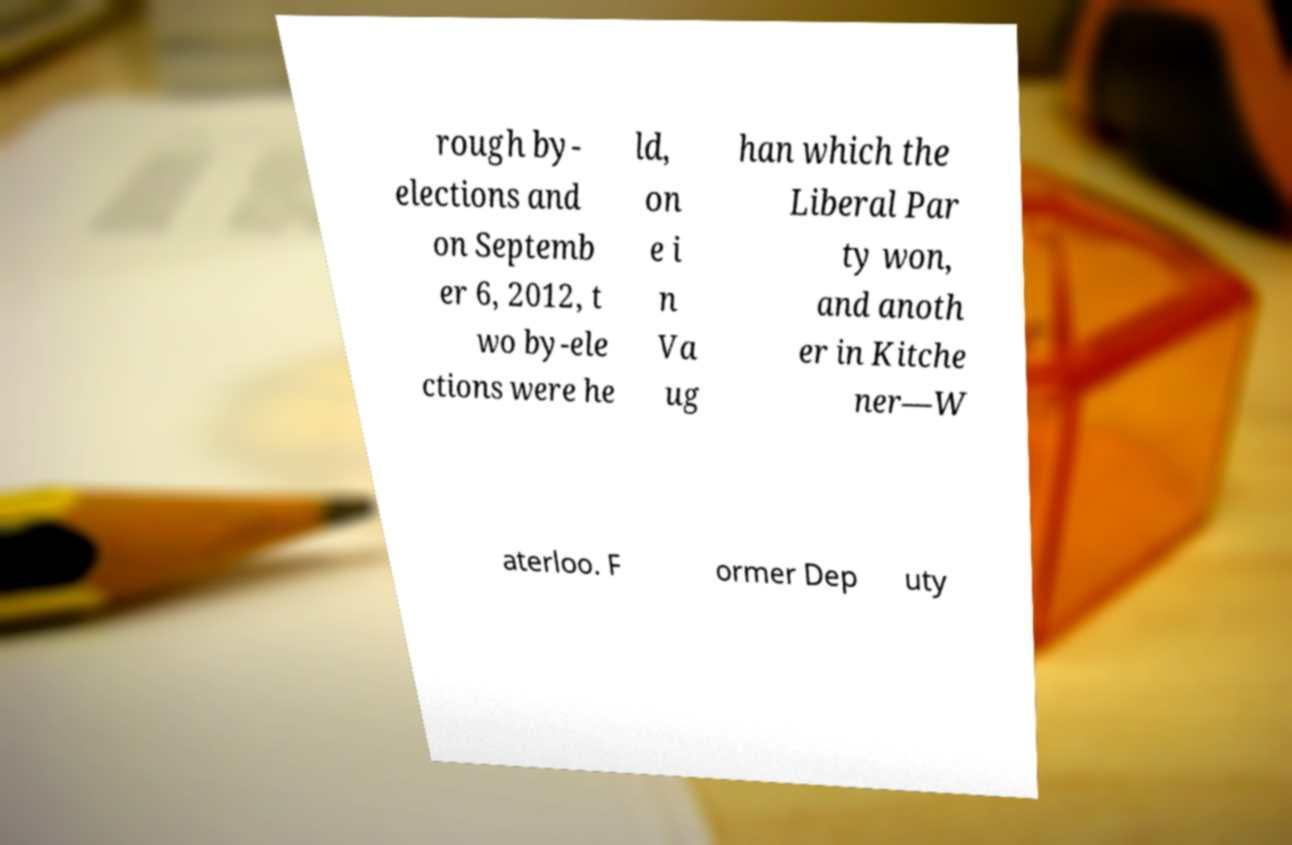Please read and relay the text visible in this image. What does it say? rough by- elections and on Septemb er 6, 2012, t wo by-ele ctions were he ld, on e i n Va ug han which the Liberal Par ty won, and anoth er in Kitche ner—W aterloo. F ormer Dep uty 